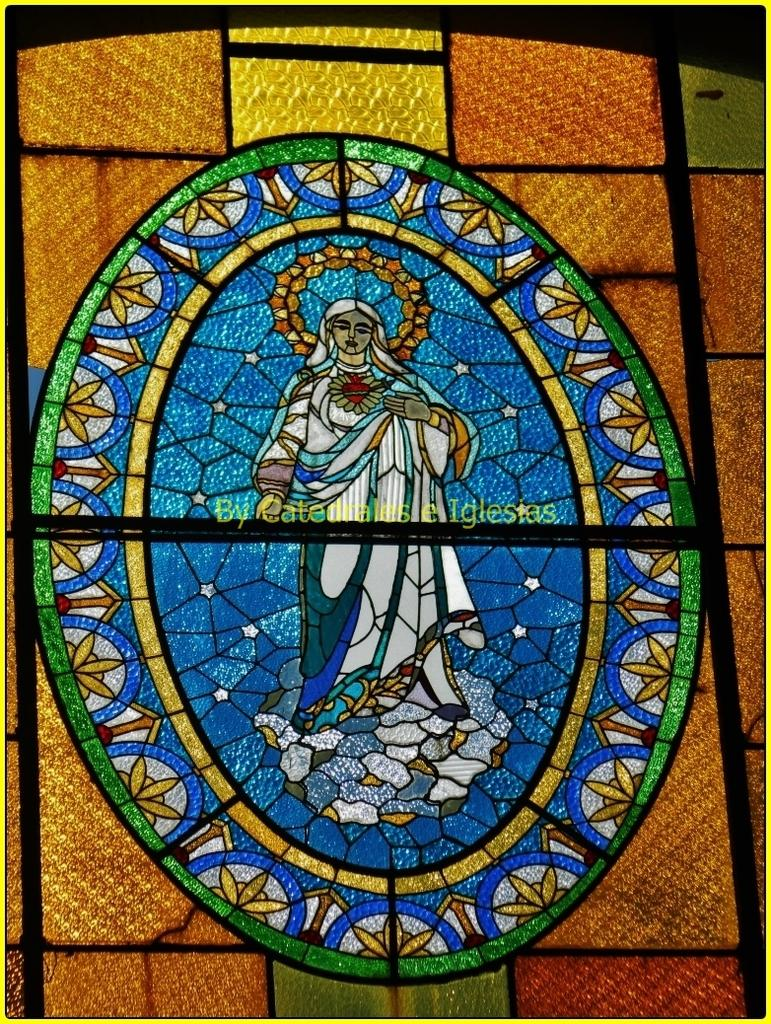What type of artwork is featured in the image? There is a glass painting in the image. Where is the glass painting located? The glass painting is on a window-like object. Can you see any poisonous substances in the image? There is no mention of poisonous substances in the image; it features a glass painting on a window-like object. 